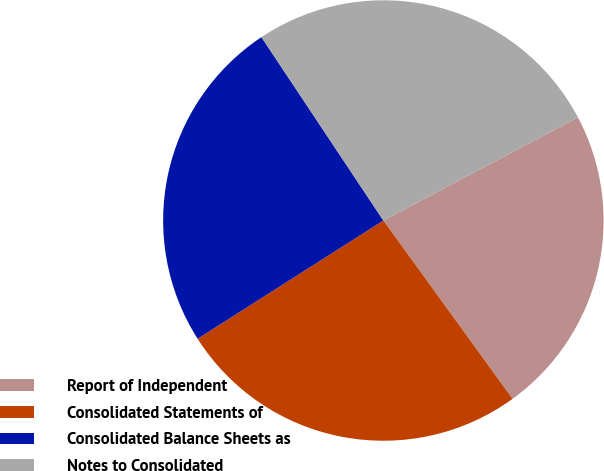Convert chart. <chart><loc_0><loc_0><loc_500><loc_500><pie_chart><fcel>Report of Independent<fcel>Consolidated Statements of<fcel>Consolidated Balance Sheets as<fcel>Notes to Consolidated<nl><fcel>22.78%<fcel>25.95%<fcel>24.68%<fcel>26.58%<nl></chart> 